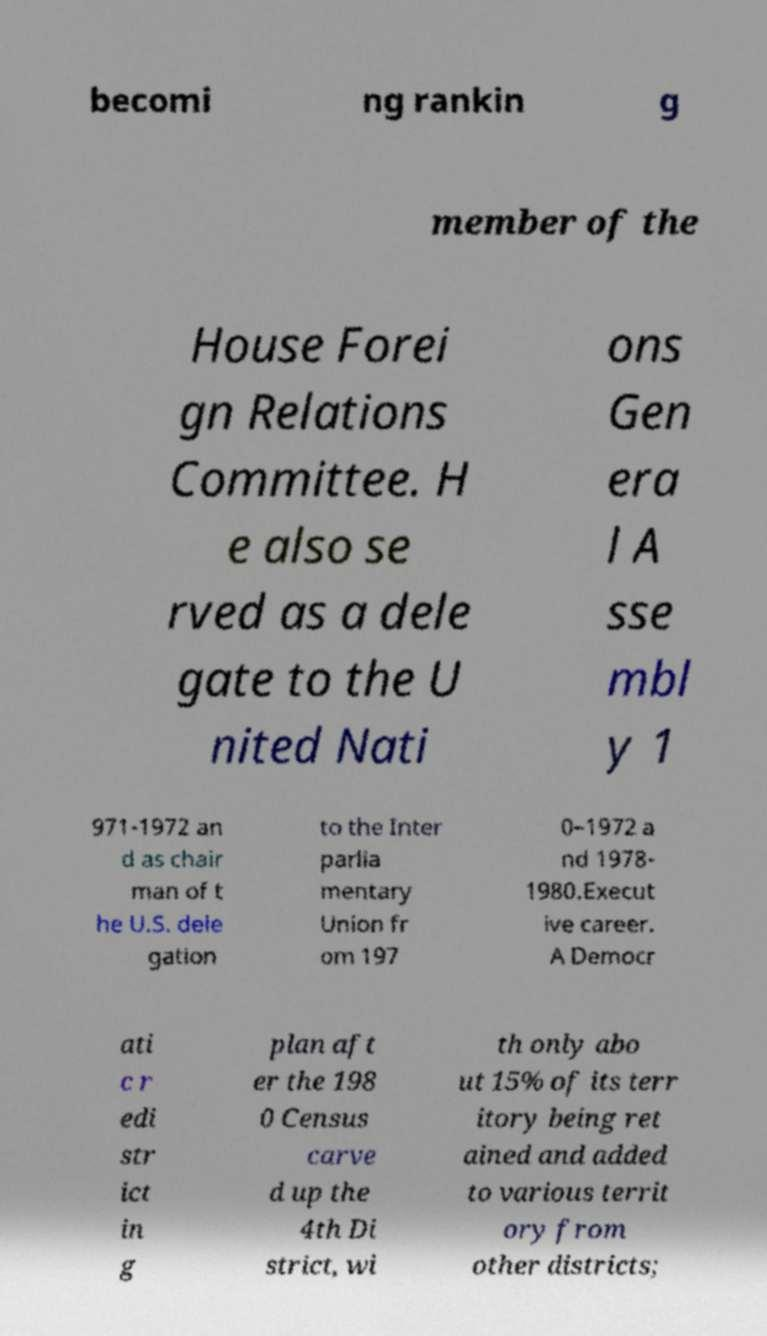There's text embedded in this image that I need extracted. Can you transcribe it verbatim? becomi ng rankin g member of the House Forei gn Relations Committee. H e also se rved as a dele gate to the U nited Nati ons Gen era l A sse mbl y 1 971-1972 an d as chair man of t he U.S. dele gation to the Inter parlia mentary Union fr om 197 0–1972 a nd 1978- 1980.Execut ive career. A Democr ati c r edi str ict in g plan aft er the 198 0 Census carve d up the 4th Di strict, wi th only abo ut 15% of its terr itory being ret ained and added to various territ ory from other districts; 